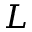<formula> <loc_0><loc_0><loc_500><loc_500>L</formula> 